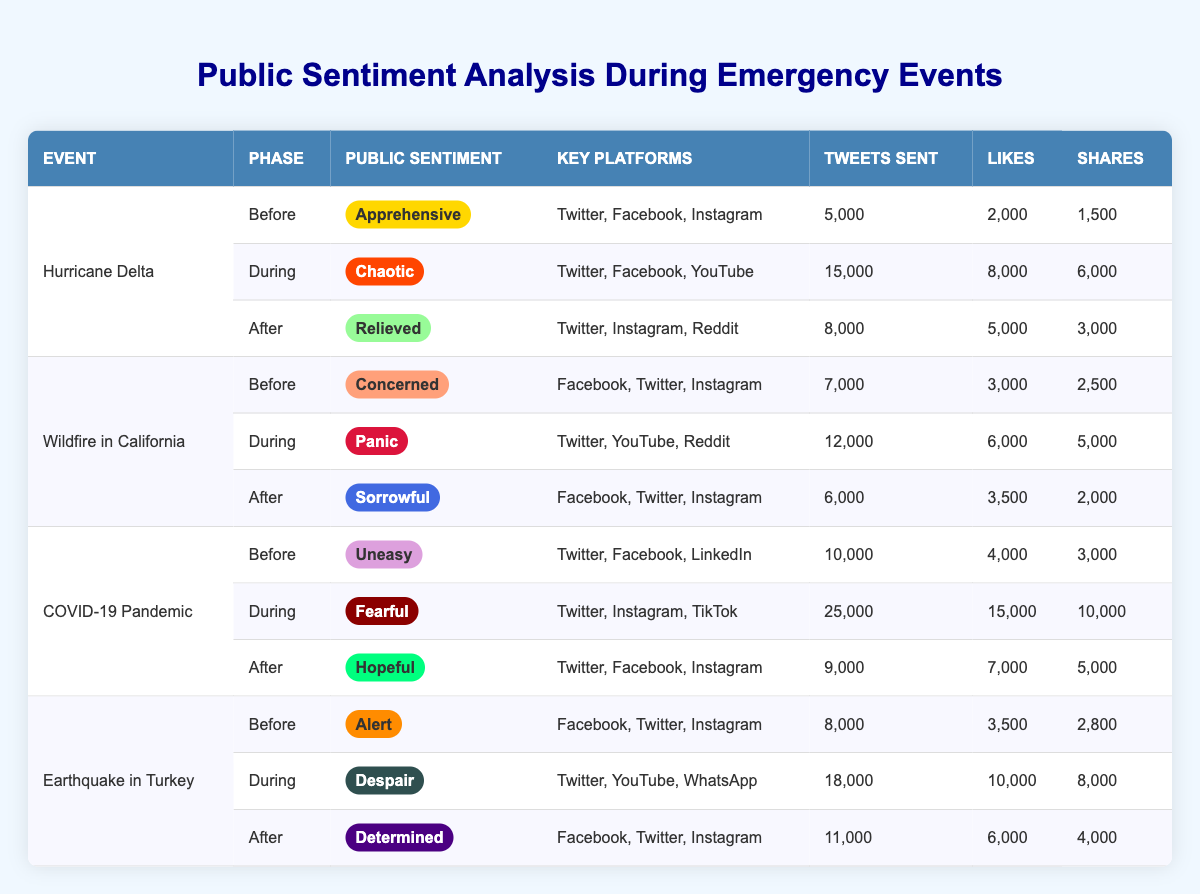What was the public sentiment during the Wildfire in California? During the Wildfire in California, the public sentiment was "Panic," as reflected in the table under the corresponding event and phase.
Answer: Panic Which social media platform was primarily used during the COVID-19 pandemic when the public sentiment was fearful? The table indicates that during the COVID-19 Pandemic when the public sentiment was "Fearful," the primary platforms were Twitter, Instagram, and TikTok.
Answer: Twitter, Instagram, TikTok How many tweets were sent during the Earthquake in Turkey? To find the total tweets sent during the Earthquake in Turkey, we look at the rows associated with this event. The total tweets during the phases were 8,000 (Before) + 18,000 (During) + 11,000 (After) = 37,000 tweets.
Answer: 37,000 Did public sentiment improve from the "During" phase to the "After" phase for Hurricane Delta? Comparing the sentiments, "Chaotic" (During) to "Relieved" (After) shows an improvement in public sentiment, indicating a positive change.
Answer: Yes What is the average number of shares across all events during the After phase? To calculate the average shares for the After phase, we first find the shares for each event: Hurricane Delta (3,000) + Wildfire in California (2,000) + COVID-19 Pandemic (5,000) + Earthquake in Turkey (4,000) = 14,000. There are 4 events, so the average is 14,000 / 4 = 3,500 shares.
Answer: 3,500 Which event had the highest engagement metrics in the During phase based on tweets sent? In the During phase, COVID-19 Pandemic had the highest number of tweets sent with a total of 25,000, which is higher than the other events listed in the table.
Answer: COVID-19 Pandemic What was the public sentiment immediately after the Wildfire in California? According to the table, immediately after the Wildfire in California, the public sentiment was "Sorrowful," as indicated in the After phase for that event.
Answer: Sorrowful Was the public sentiment during the Earthquake in Turkey classified as "Despair"? The sentiment during the Earthquake in Turkey's During phase was indeed "Despair," confirming the classification.
Answer: Yes Which event had the least number of likes during the After phase? By examining the After phase likes, the Wildfire in California had the least number of likes at 3,500, compared to other events, confirming it as the lowest.
Answer: Wildfire in California 